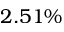<formula> <loc_0><loc_0><loc_500><loc_500>2 . 5 1 \%</formula> 